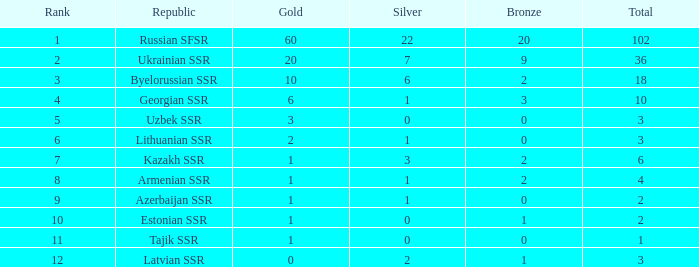For teams with more than one gold, a ranking higher than 3, and over three bronze medals, what is the average cumulative total? None. 